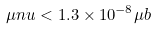Convert formula to latex. <formula><loc_0><loc_0><loc_500><loc_500>\mu n u < 1 . 3 \times 1 0 ^ { - 8 } \mu b</formula> 